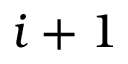Convert formula to latex. <formula><loc_0><loc_0><loc_500><loc_500>i + 1</formula> 